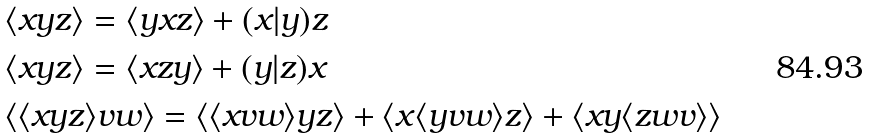<formula> <loc_0><loc_0><loc_500><loc_500>& \langle x y z \rangle = \langle y x z \rangle + ( x | y ) z \\ & \langle x y z \rangle = \langle x z y \rangle + ( y | z ) x \\ & \langle \langle x y z \rangle v w \rangle = \langle \langle x v w \rangle y z \rangle + \langle x \langle y v w \rangle z \rangle + \langle x y \langle z w v \rangle \rangle</formula> 